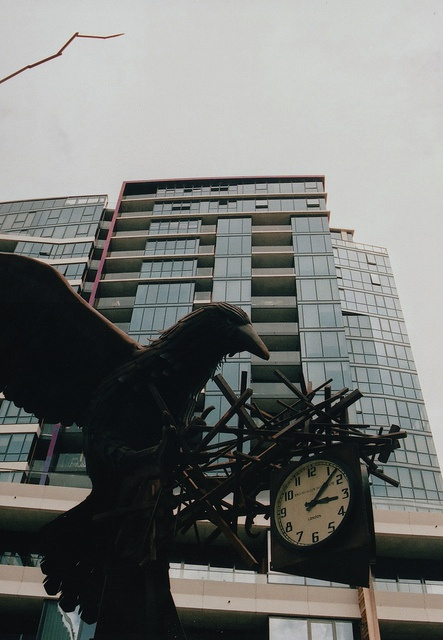Describe the objects in this image and their specific colors. I can see bird in lightgray, black, gray, and darkgray tones and clock in lightgray, gray, black, and darkgreen tones in this image. 